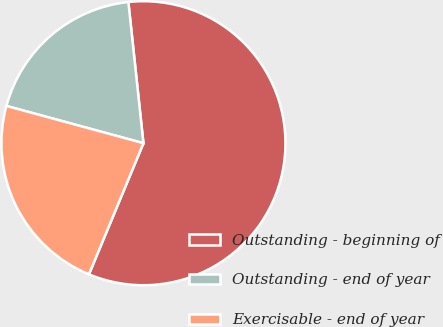<chart> <loc_0><loc_0><loc_500><loc_500><pie_chart><fcel>Outstanding - beginning of<fcel>Outstanding - end of year<fcel>Exercisable - end of year<nl><fcel>57.96%<fcel>19.08%<fcel>22.96%<nl></chart> 